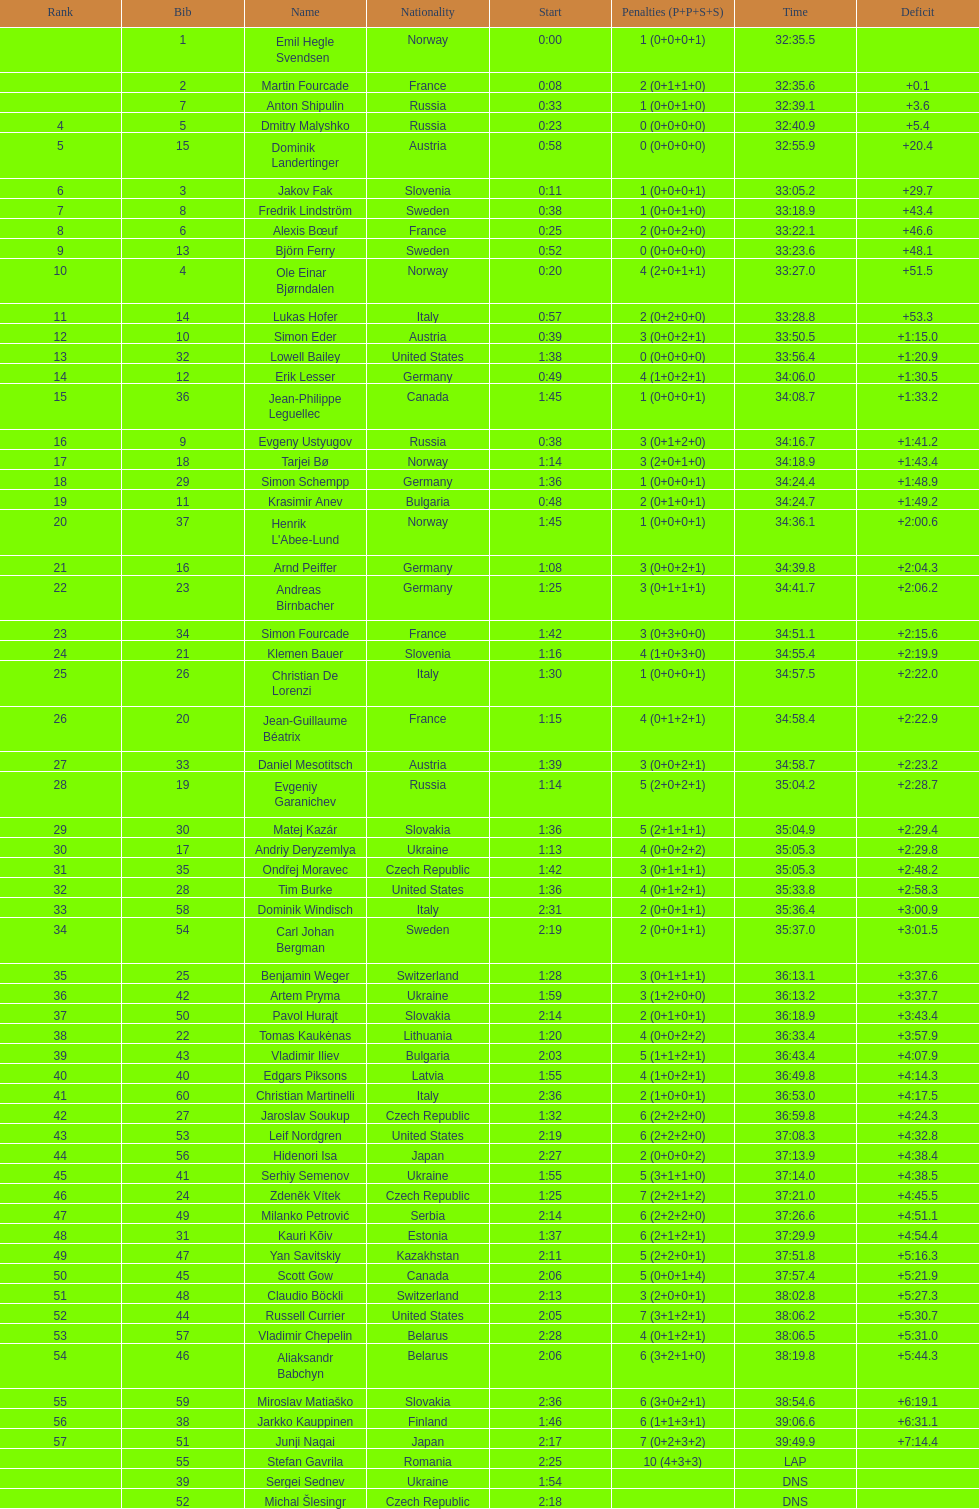What is the combined number of participants from norway and france? 7. 